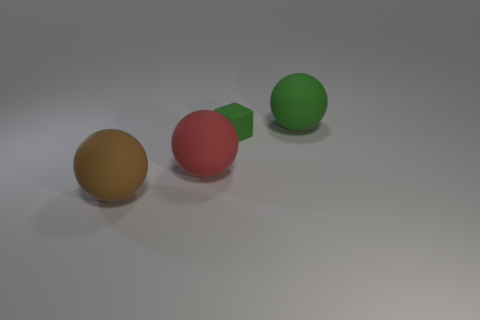Add 3 red rubber things. How many objects exist? 7 Subtract 1 balls. How many balls are left? 2 Subtract all purple balls. Subtract all blue cylinders. How many balls are left? 3 Subtract all cubes. How many objects are left? 3 Subtract all brown objects. Subtract all small rubber things. How many objects are left? 2 Add 4 rubber spheres. How many rubber spheres are left? 7 Add 1 big green balls. How many big green balls exist? 2 Subtract 0 cyan cubes. How many objects are left? 4 